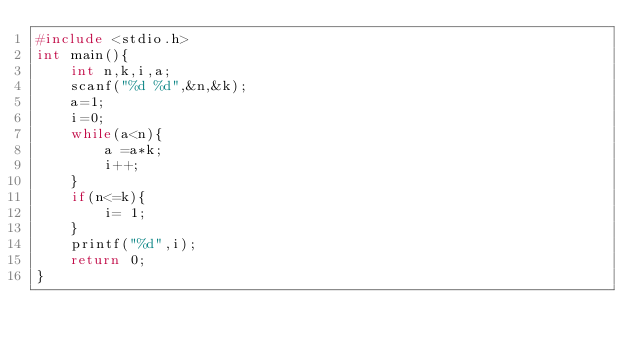Convert code to text. <code><loc_0><loc_0><loc_500><loc_500><_C_>#include <stdio.h>
int main(){
    int n,k,i,a;
    scanf("%d %d",&n,&k);
    a=1;
    i=0;
    while(a<n){
        a =a*k;
        i++;
    }
    if(n<=k){
        i= 1;
    }
    printf("%d",i);
    return 0;
}
</code> 